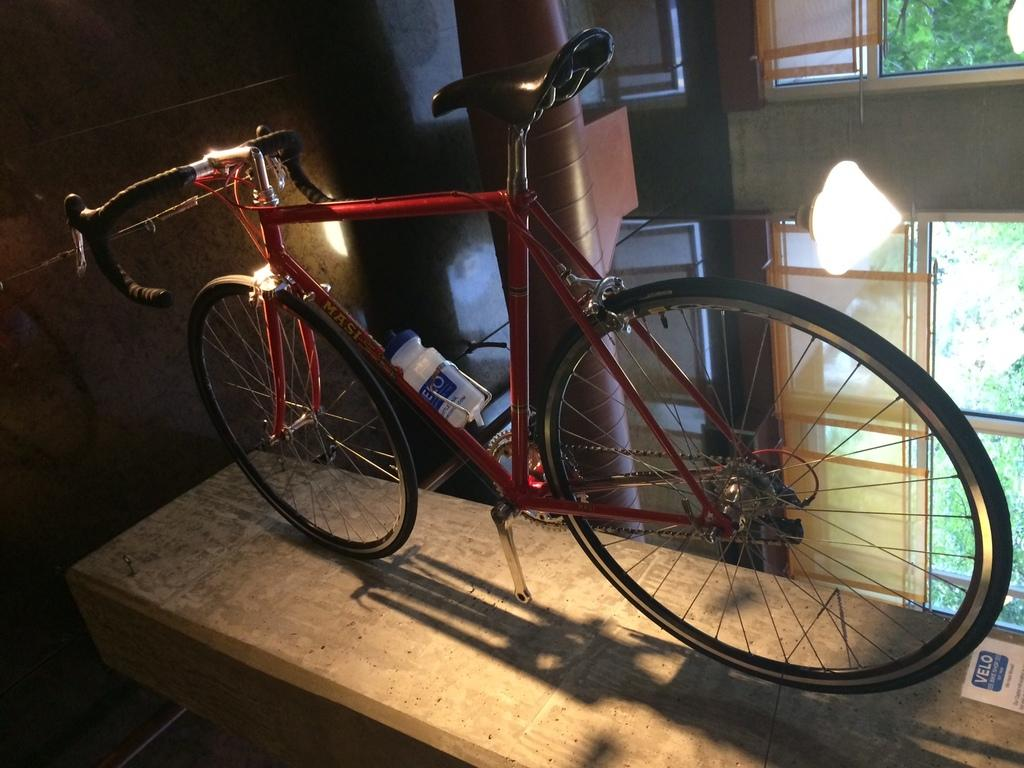What is the main object on the platform in the image? There is a bicycle on a platform in the image. What other item can be seen in the image? There is a bottle in the image. What type of decoration is present in the image? There is a sticker in the image. What type of structure is visible in the image? There is a wall in the image. What architectural feature can be seen in the image? There is a pillar in the image. What can be seen through the windows in the image? Trees are visible through the windows in the image. What type of leather is used to make the desk in the image? There is no desk present in the image, so it is not possible to determine the type of leather used. 